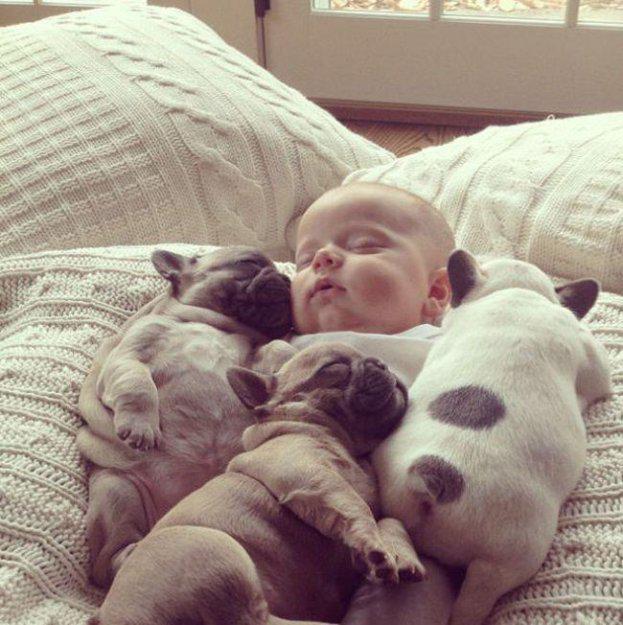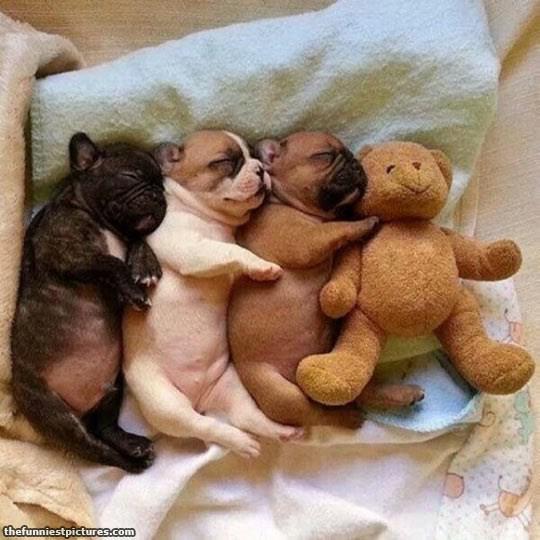The first image is the image on the left, the second image is the image on the right. Assess this claim about the two images: "An image shows a human child resting with at least one snoozing dog.". Correct or not? Answer yes or no. Yes. The first image is the image on the left, the second image is the image on the right. Assess this claim about the two images: "A young person is lying with at least one dog.". Correct or not? Answer yes or no. Yes. 